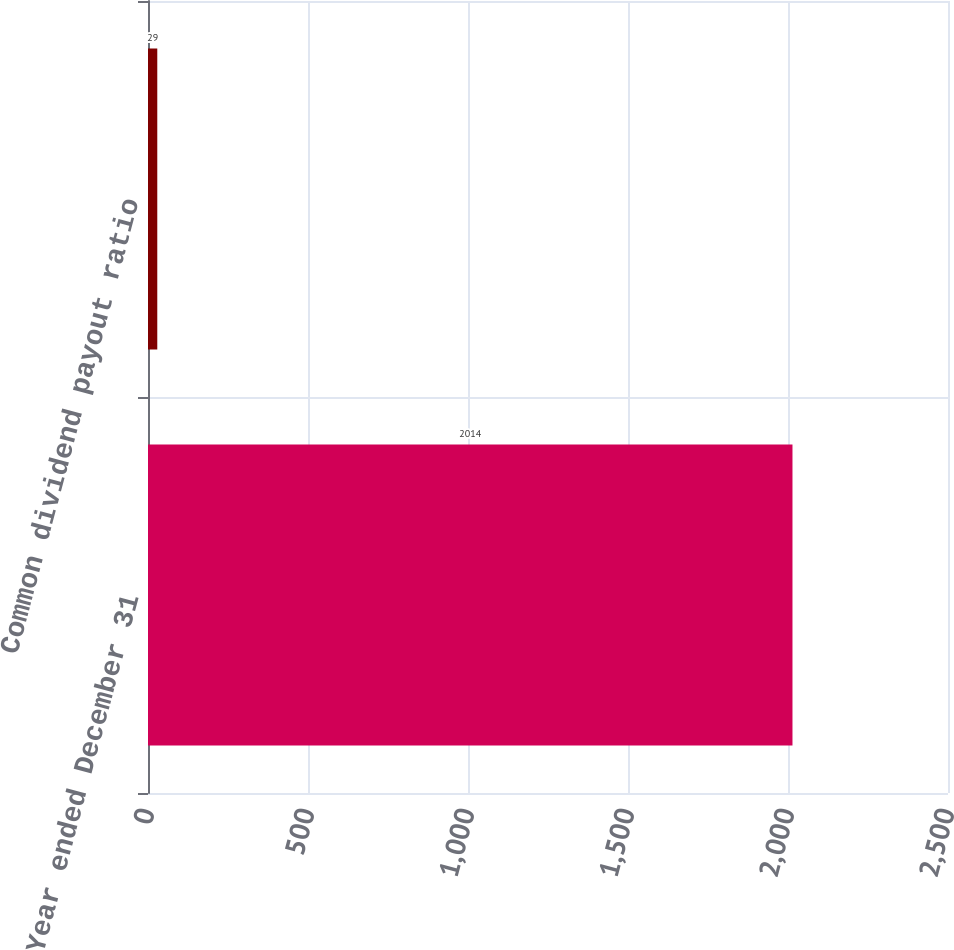Convert chart. <chart><loc_0><loc_0><loc_500><loc_500><bar_chart><fcel>Year ended December 31<fcel>Common dividend payout ratio<nl><fcel>2014<fcel>29<nl></chart> 